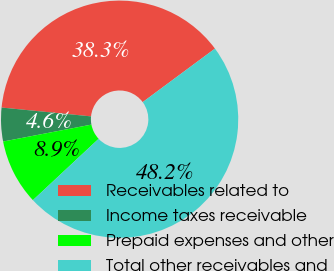Convert chart to OTSL. <chart><loc_0><loc_0><loc_500><loc_500><pie_chart><fcel>Receivables related to<fcel>Income taxes receivable<fcel>Prepaid expenses and other<fcel>Total other receivables and<nl><fcel>38.29%<fcel>4.58%<fcel>8.94%<fcel>48.19%<nl></chart> 